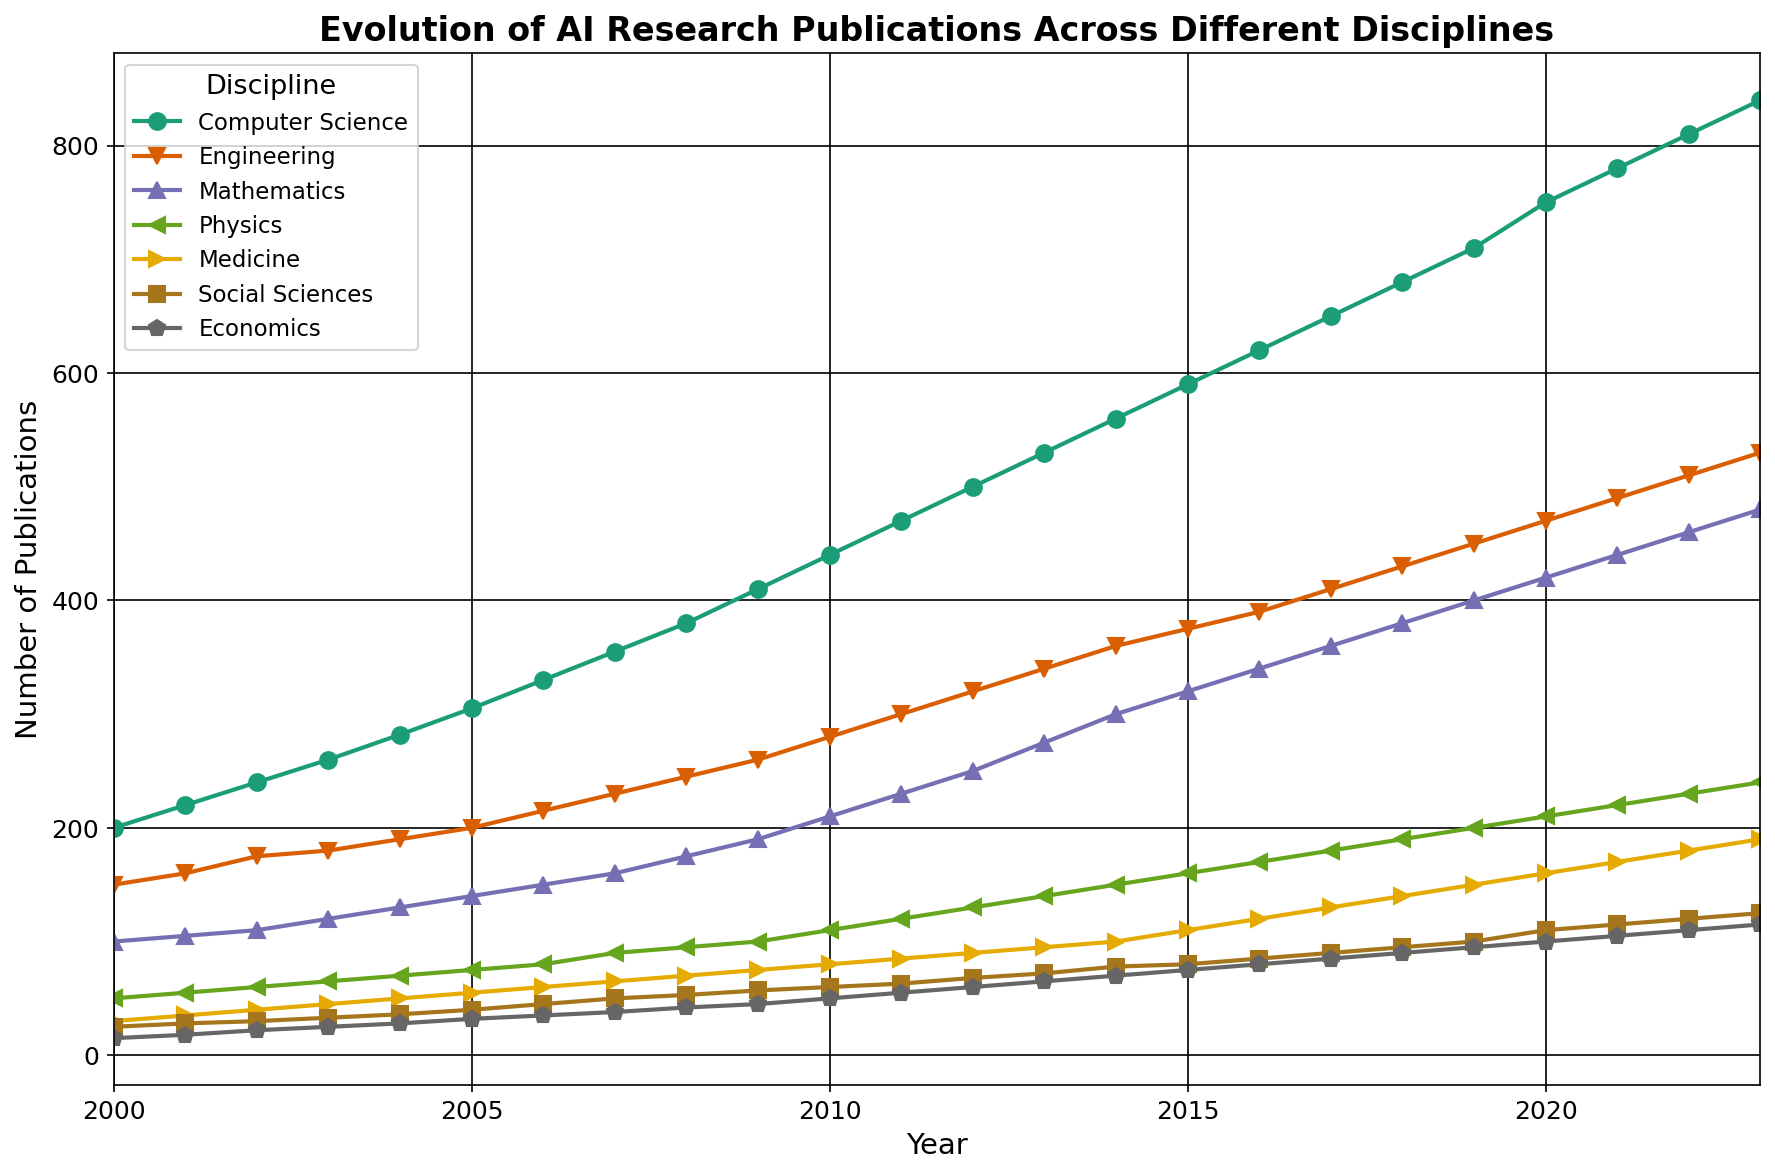Which discipline shows the highest number of AI research publications in 2023? Looking at the line chart, the Computer Science line is the highest in 2023
Answer: Computer Science Which discipline has the lowest number of AI research publications in 2000? In 2000, the line for Economics is the lowest
Answer: Economics How many more AI research publications are there in Computer Science compared to Medicine in 2023? The number of publications in Computer Science in 2023 is 840, and in Medicine, it is 190. The difference is 840 - 190 = 650
Answer: 650 In which year did Engineering overtake Mathematics in the number of AI research publications? Looking at the lines for Engineering and Mathematics, Engineering surpasses Mathematics in 2002
Answer: 2002 What is the average number of AI research publications in Physics from 2000 to 2023? Sum of Physics publications from 2000 to 2023 is 50 + 55 + 60 + 65 + 70 + 75 + 80 + 90 + 95 + 100 + 110 + 120 + 130 + 140 + 150 + 160 + 170 + 180 + 190 + 200 + 210 + 220 + 230 + 240 = 3275. Average is 3275 / 24 = 136.46
Answer: 136.46 Which discipline has seen the most consistent growth in AI research publications over the years? All lines are increasing, but the Computer Science line shows the most consistent and steep growth without decline
Answer: Computer Science In which year did the number of AI research publications in Social Sciences first exceed 50? The Social Sciences line first hits 50 in 2008
Answer: 2008 What is the combined total of AI research publications in Medicine and Economics in 2023? Publications in Medicine in 2023 is 190, and in Economics it is 115. The combined total is 190 + 115 = 305
Answer: 305 